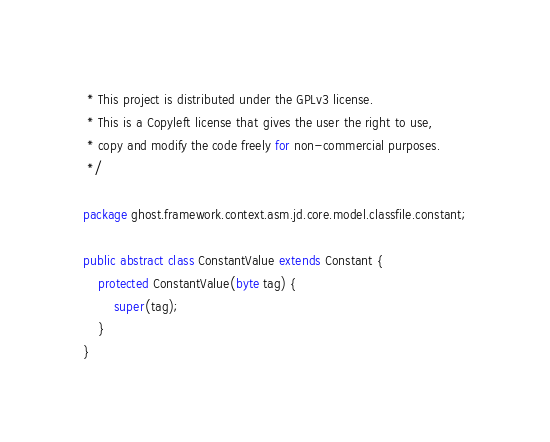<code> <loc_0><loc_0><loc_500><loc_500><_Java_> * This project is distributed under the GPLv3 license.
 * This is a Copyleft license that gives the user the right to use,
 * copy and modify the code freely for non-commercial purposes.
 */

package ghost.framework.context.asm.jd.core.model.classfile.constant;

public abstract class ConstantValue extends Constant {
    protected ConstantValue(byte tag) {
        super(tag);
    }
}
</code> 